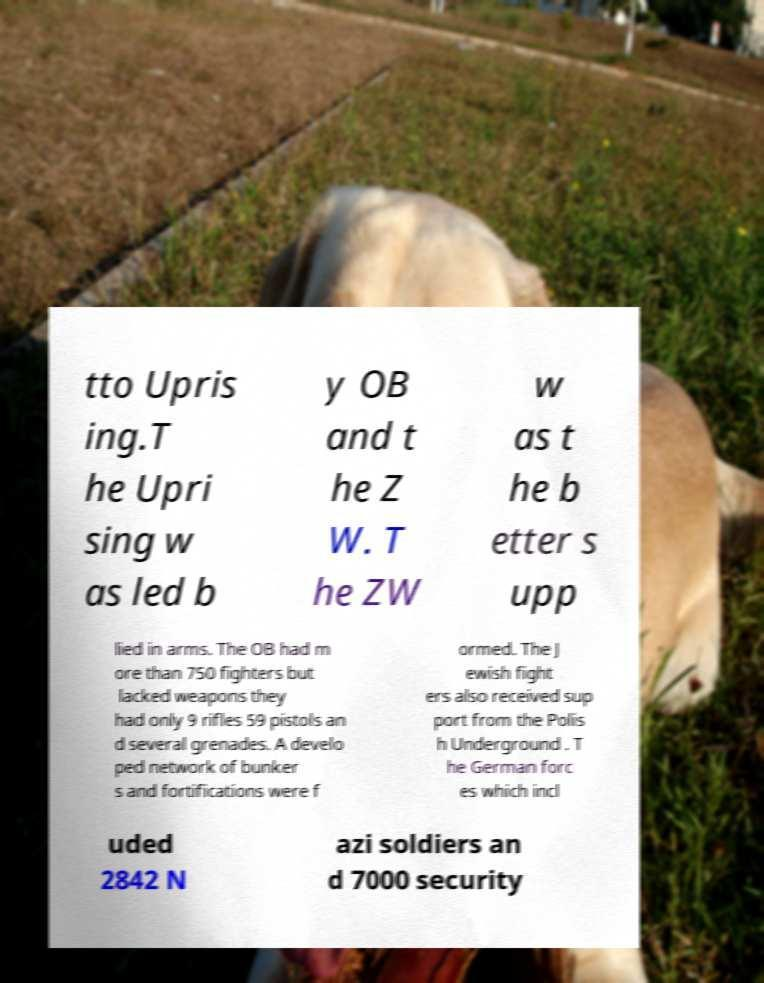What messages or text are displayed in this image? I need them in a readable, typed format. tto Upris ing.T he Upri sing w as led b y OB and t he Z W. T he ZW w as t he b etter s upp lied in arms. The OB had m ore than 750 fighters but lacked weapons they had only 9 rifles 59 pistols an d several grenades. A develo ped network of bunker s and fortifications were f ormed. The J ewish fight ers also received sup port from the Polis h Underground . T he German forc es which incl uded 2842 N azi soldiers an d 7000 security 